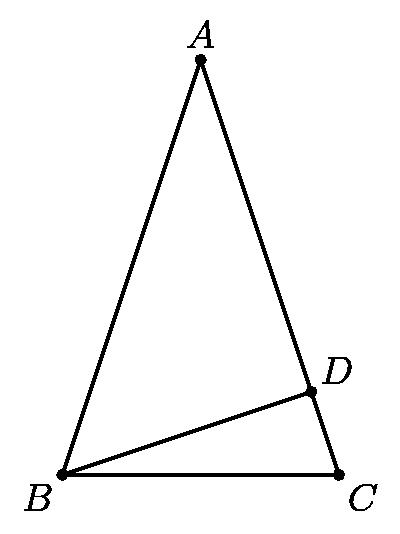Consider all triangles $ ABC$ satisfying the following conditions: $ AB = AC$, $ D$ is a point on $ \overline{AC}$ for which $ \overline{BD} \perp \overline{AC}$, $ AD$ and $ CD$ are integers, and $ BD^2 = 57$. 
Among all such triangles, the smallest possible value of $ AC$ is Answer is 11. 